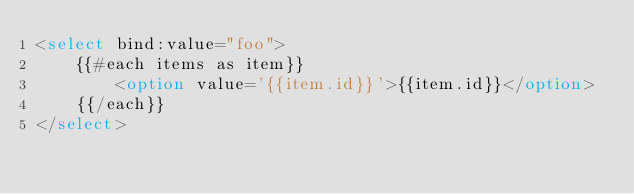<code> <loc_0><loc_0><loc_500><loc_500><_HTML_><select bind:value="foo">
	{{#each items as item}}
		<option value='{{item.id}}'>{{item.id}}</option>
	{{/each}}
</select>
</code> 